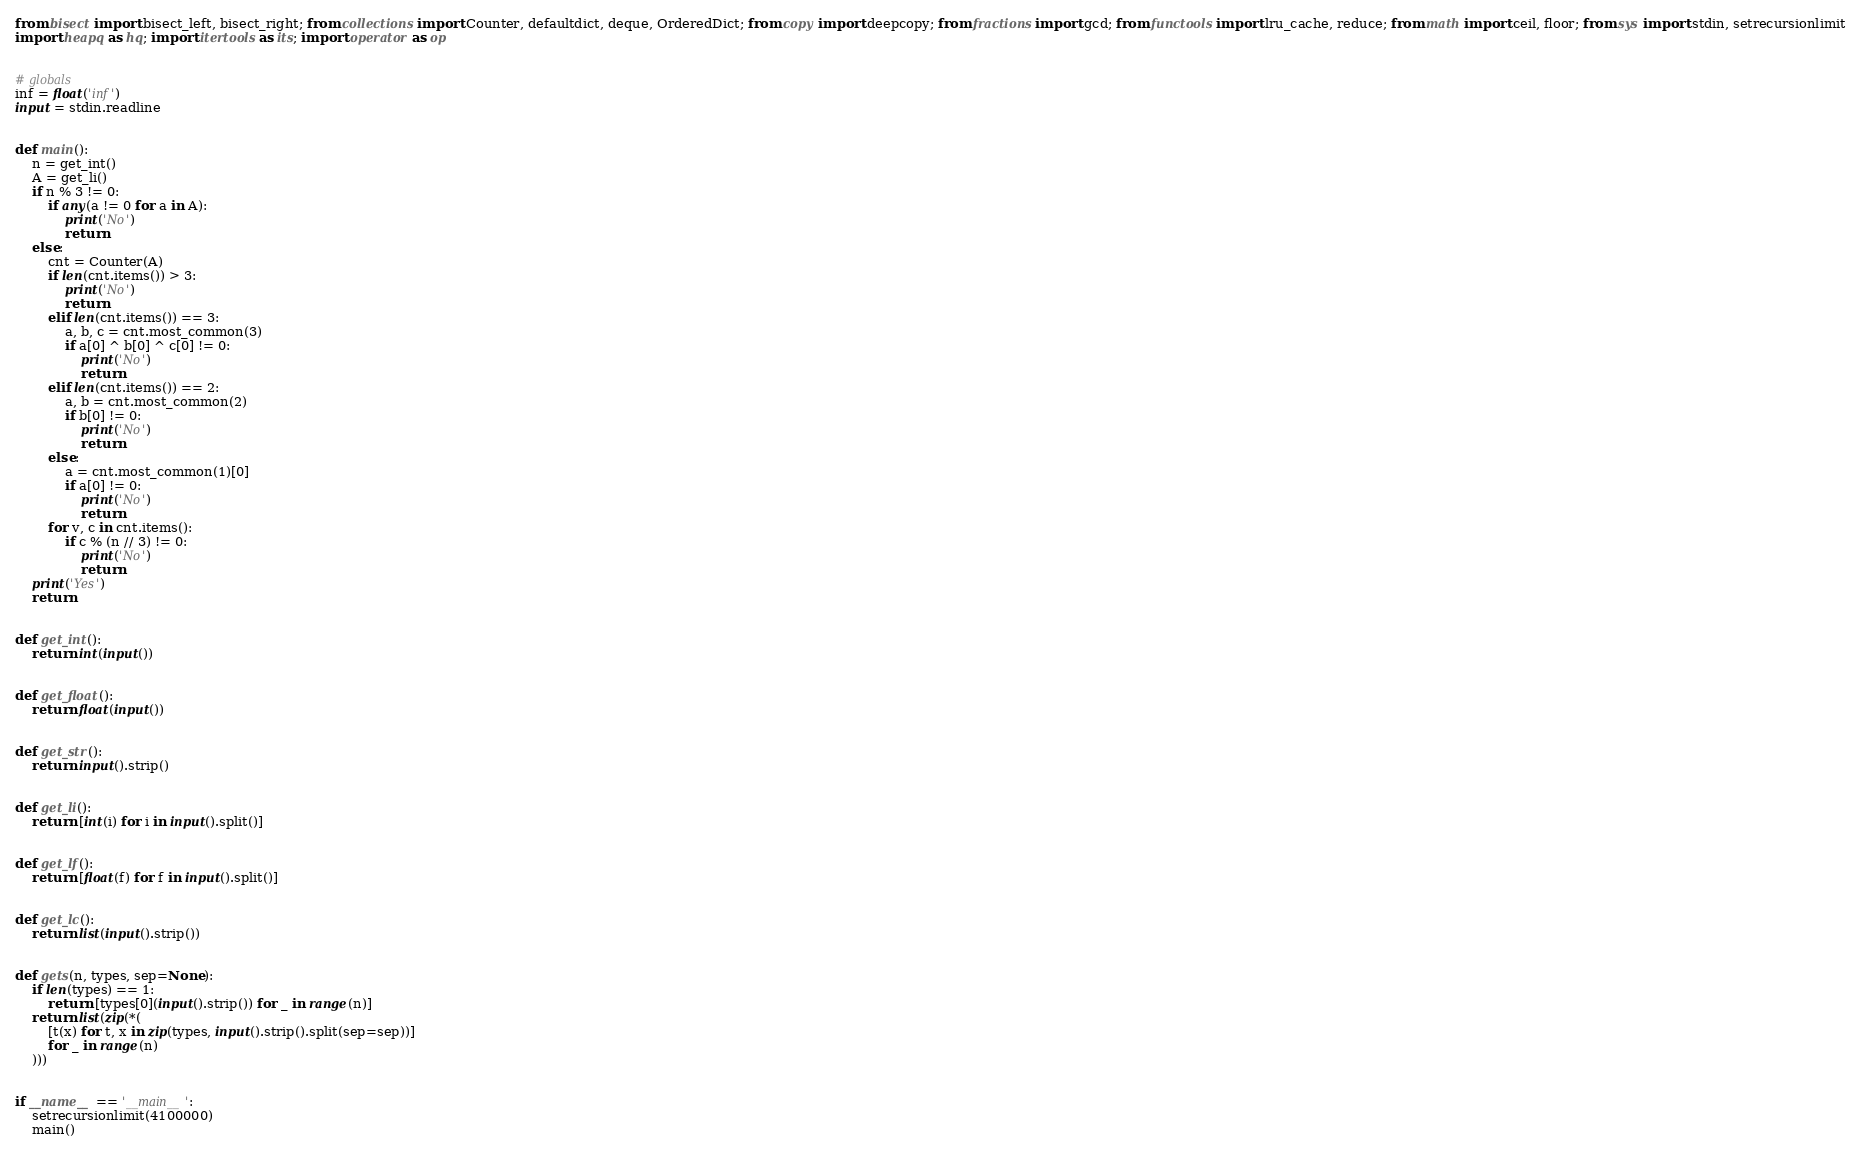Convert code to text. <code><loc_0><loc_0><loc_500><loc_500><_Python_>from bisect import bisect_left, bisect_right; from collections import Counter, defaultdict, deque, OrderedDict; from copy import deepcopy; from fractions import gcd; from functools import lru_cache, reduce; from math import ceil, floor; from sys import stdin, setrecursionlimit
import heapq as hq; import itertools as its; import operator as op


# globals
inf = float('inf')
input = stdin.readline


def main():
    n = get_int()
    A = get_li()
    if n % 3 != 0:
        if any(a != 0 for a in A):
            print('No')
            return
    else:
        cnt = Counter(A)
        if len(cnt.items()) > 3:
            print('No')
            return
        elif len(cnt.items()) == 3:
            a, b, c = cnt.most_common(3)
            if a[0] ^ b[0] ^ c[0] != 0:
                print('No')
                return
        elif len(cnt.items()) == 2:
            a, b = cnt.most_common(2)
            if b[0] != 0:
                print('No')
                return
        else:
            a = cnt.most_common(1)[0]
            if a[0] != 0:
                print('No')
                return
        for v, c in cnt.items():
            if c % (n // 3) != 0:
                print('No')
                return
    print('Yes')
    return


def get_int():
    return int(input())


def get_float():
    return float(input())


def get_str():
    return input().strip()


def get_li():
    return [int(i) for i in input().split()]


def get_lf():
    return [float(f) for f in input().split()]


def get_lc():
    return list(input().strip())


def gets(n, types, sep=None):
    if len(types) == 1:
        return [types[0](input().strip()) for _ in range(n)]
    return list(zip(*(
        [t(x) for t, x in zip(types, input().strip().split(sep=sep))]
        for _ in range(n)
    )))


if __name__ == '__main__':
    setrecursionlimit(4100000)
    main()
</code> 